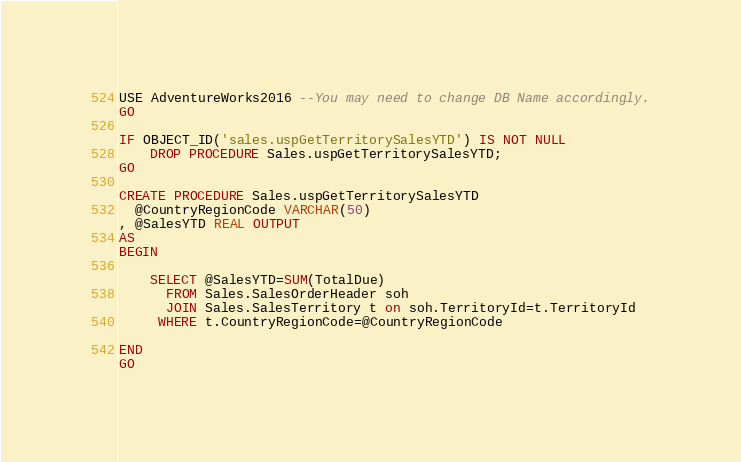<code> <loc_0><loc_0><loc_500><loc_500><_SQL_>USE AdventureWorks2016 --You may need to change DB Name accordingly.
GO

IF OBJECT_ID('sales.uspGetTerritorySalesYTD') IS NOT NULL
    DROP PROCEDURE Sales.uspGetTerritorySalesYTD; 
GO

CREATE PROCEDURE Sales.uspGetTerritorySalesYTD
  @CountryRegionCode VARCHAR(50)
, @SalesYTD REAL OUTPUT
AS
BEGIN

    SELECT @SalesYTD=SUM(TotalDue)
      FROM Sales.SalesOrderHeader soh 
      JOIN Sales.SalesTerritory t on soh.TerritoryId=t.TerritoryId
     WHERE t.CountryRegionCode=@CountryRegionCode

END
GO</code> 